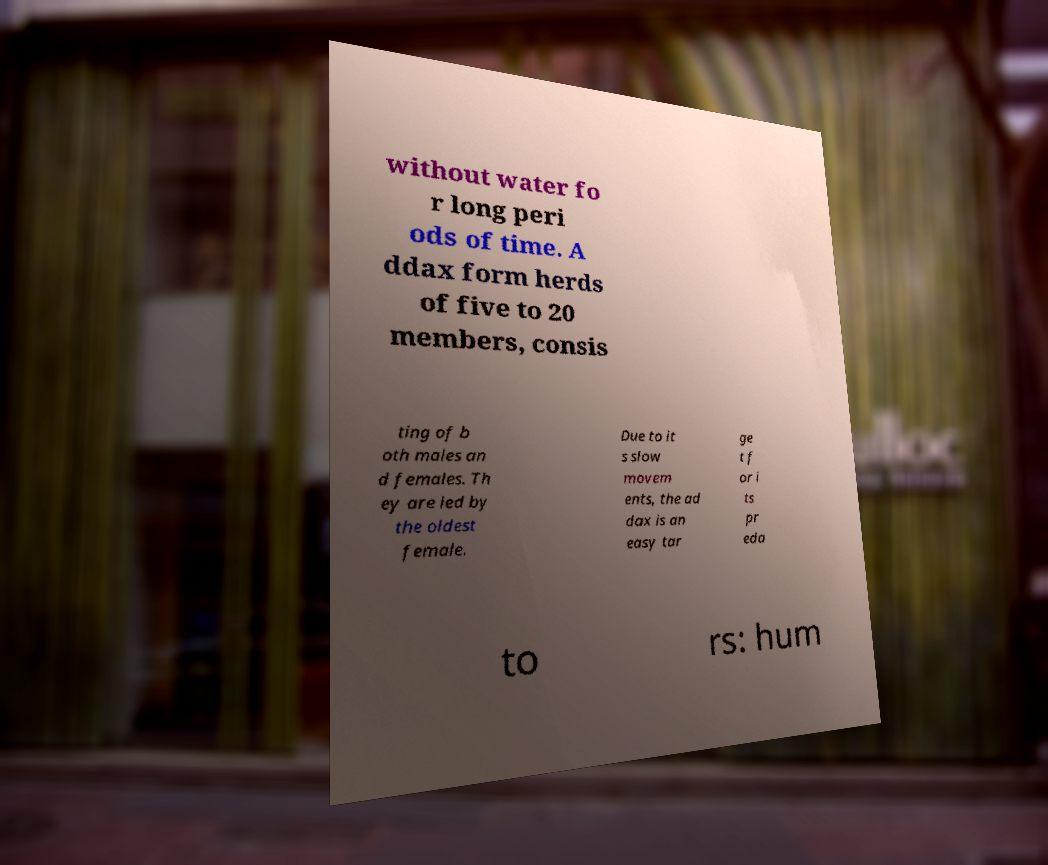I need the written content from this picture converted into text. Can you do that? without water fo r long peri ods of time. A ddax form herds of five to 20 members, consis ting of b oth males an d females. Th ey are led by the oldest female. Due to it s slow movem ents, the ad dax is an easy tar ge t f or i ts pr eda to rs: hum 